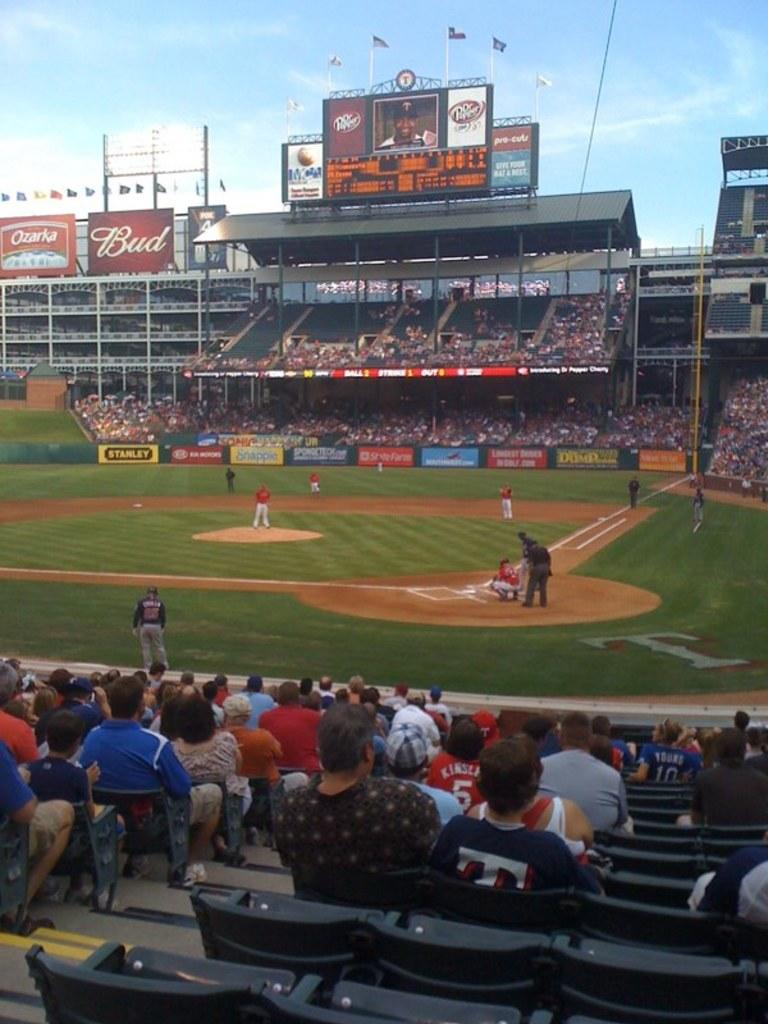<image>
Give a short and clear explanation of the subsequent image. a sign in the outfield that says Bud on it 